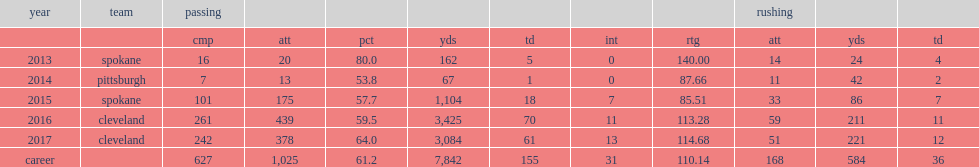How many yards did nelson throw in 2016? 3425.0. How many touchdowns did nelson throw in 2016? 70.0. 